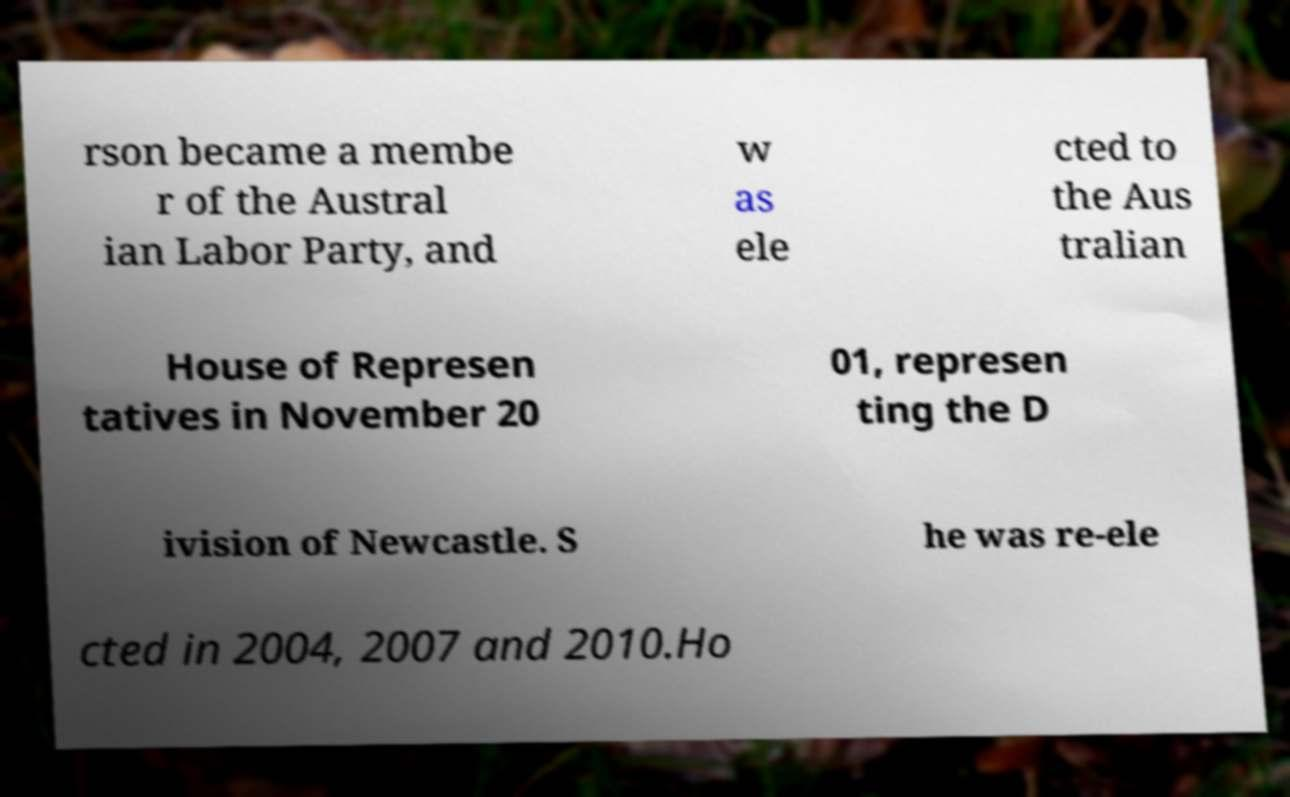What messages or text are displayed in this image? I need them in a readable, typed format. rson became a membe r of the Austral ian Labor Party, and w as ele cted to the Aus tralian House of Represen tatives in November 20 01, represen ting the D ivision of Newcastle. S he was re-ele cted in 2004, 2007 and 2010.Ho 